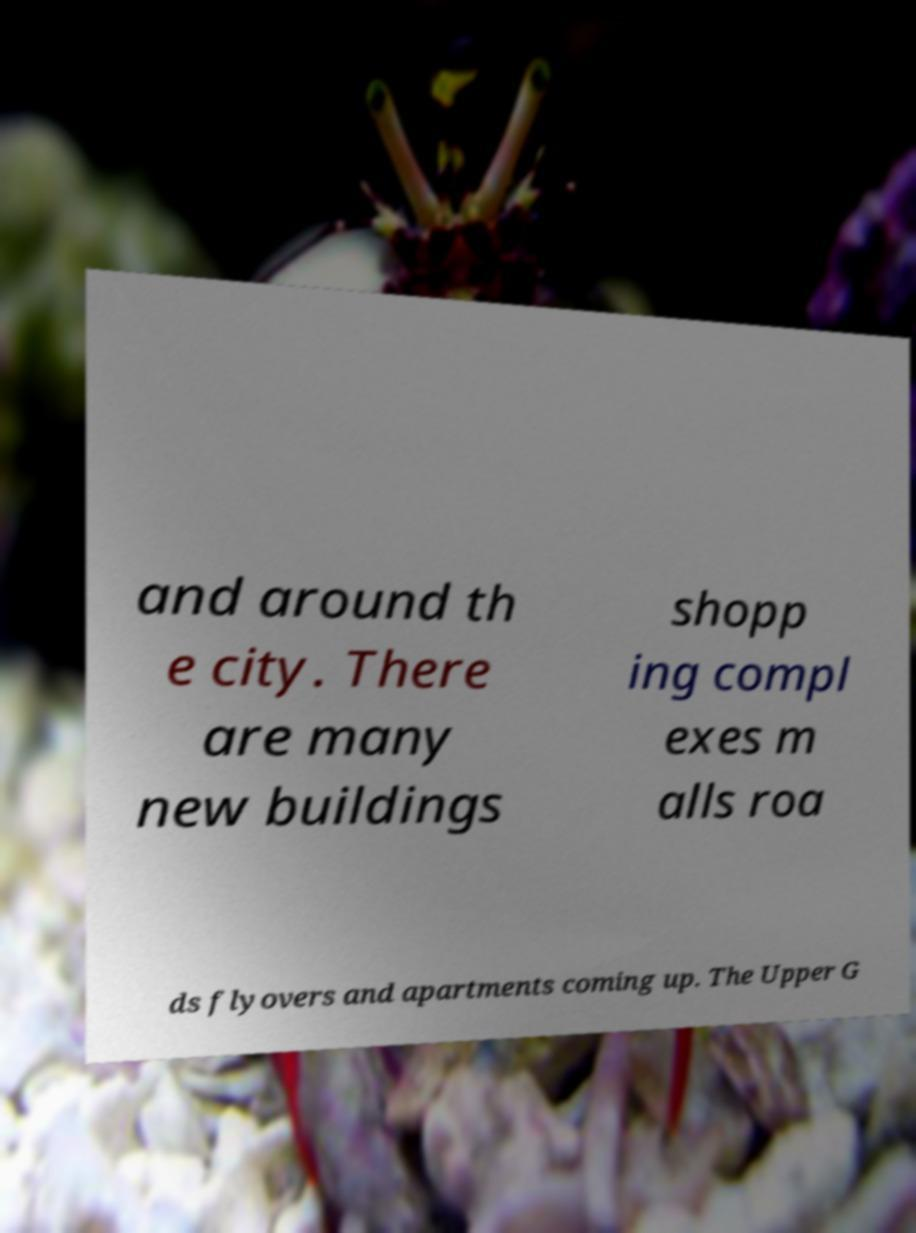Can you read and provide the text displayed in the image?This photo seems to have some interesting text. Can you extract and type it out for me? and around th e city. There are many new buildings shopp ing compl exes m alls roa ds flyovers and apartments coming up. The Upper G 